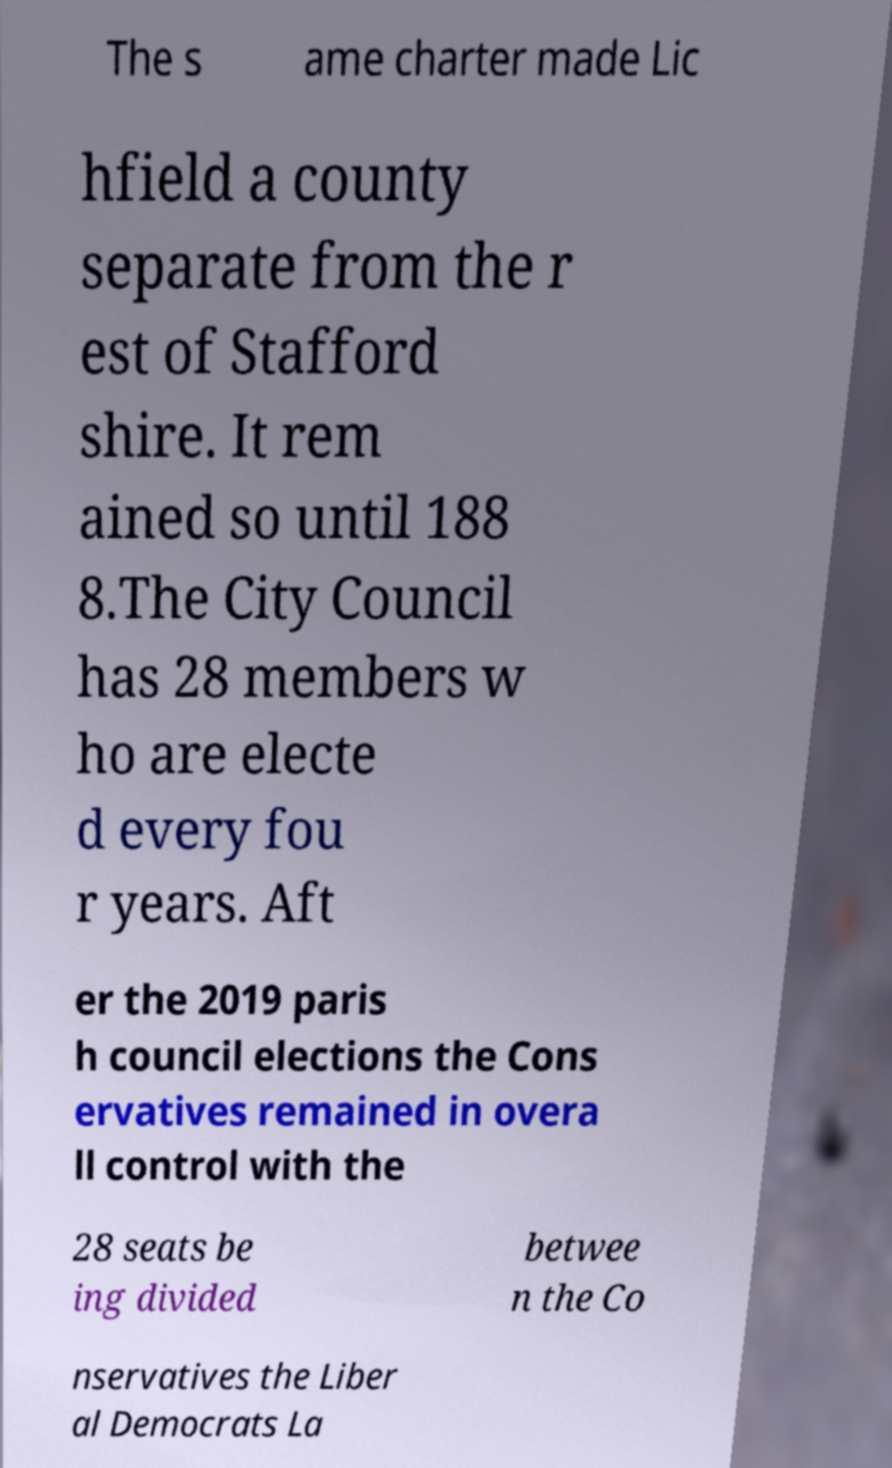Please identify and transcribe the text found in this image. The s ame charter made Lic hfield a county separate from the r est of Stafford shire. It rem ained so until 188 8.The City Council has 28 members w ho are electe d every fou r years. Aft er the 2019 paris h council elections the Cons ervatives remained in overa ll control with the 28 seats be ing divided betwee n the Co nservatives the Liber al Democrats La 